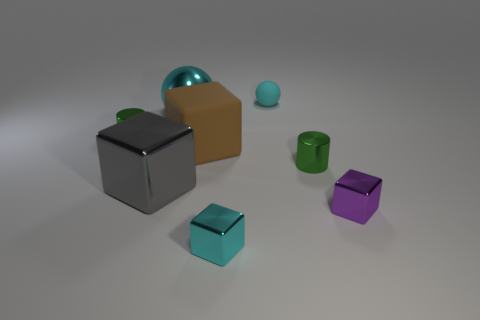Are there fewer green objects right of the purple thing than brown blocks?
Offer a terse response. Yes. Is the shape of the cyan rubber object the same as the gray metallic object?
Provide a short and direct response. No. What number of metallic things are small yellow cylinders or brown things?
Give a very brief answer. 0. Are there any objects that have the same size as the purple metallic block?
Provide a succinct answer. Yes. What shape is the small thing that is the same color as the rubber ball?
Ensure brevity in your answer.  Cube. What number of cyan rubber objects have the same size as the gray block?
Make the answer very short. 0. Is the size of the block on the left side of the brown rubber object the same as the green metal cylinder on the left side of the gray thing?
Your answer should be very brief. No. How many things are tiny green shiny cylinders or large blocks that are left of the large cyan sphere?
Provide a short and direct response. 3. What color is the small ball?
Make the answer very short. Cyan. There is a tiny cylinder in front of the tiny green cylinder behind the green metal cylinder that is right of the rubber sphere; what is its material?
Keep it short and to the point. Metal. 